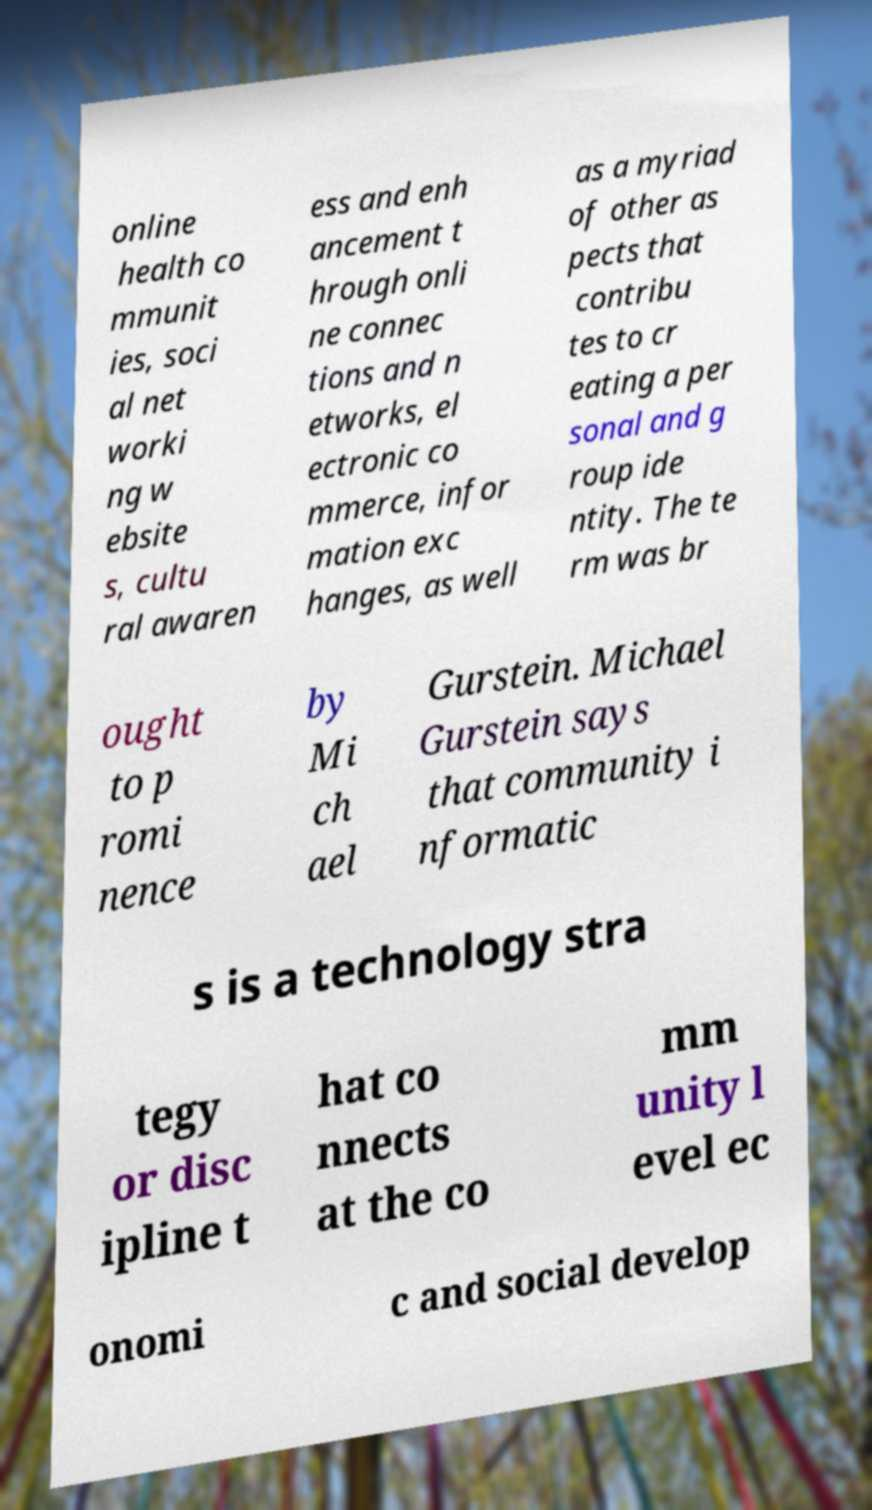What messages or text are displayed in this image? I need them in a readable, typed format. online health co mmunit ies, soci al net worki ng w ebsite s, cultu ral awaren ess and enh ancement t hrough onli ne connec tions and n etworks, el ectronic co mmerce, infor mation exc hanges, as well as a myriad of other as pects that contribu tes to cr eating a per sonal and g roup ide ntity. The te rm was br ought to p romi nence by Mi ch ael Gurstein. Michael Gurstein says that community i nformatic s is a technology stra tegy or disc ipline t hat co nnects at the co mm unity l evel ec onomi c and social develop 